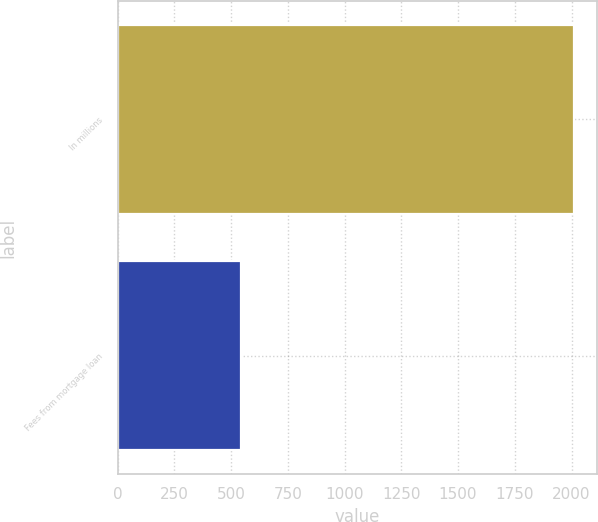Convert chart. <chart><loc_0><loc_0><loc_500><loc_500><bar_chart><fcel>In millions<fcel>Fees from mortgage loan<nl><fcel>2013<fcel>544<nl></chart> 